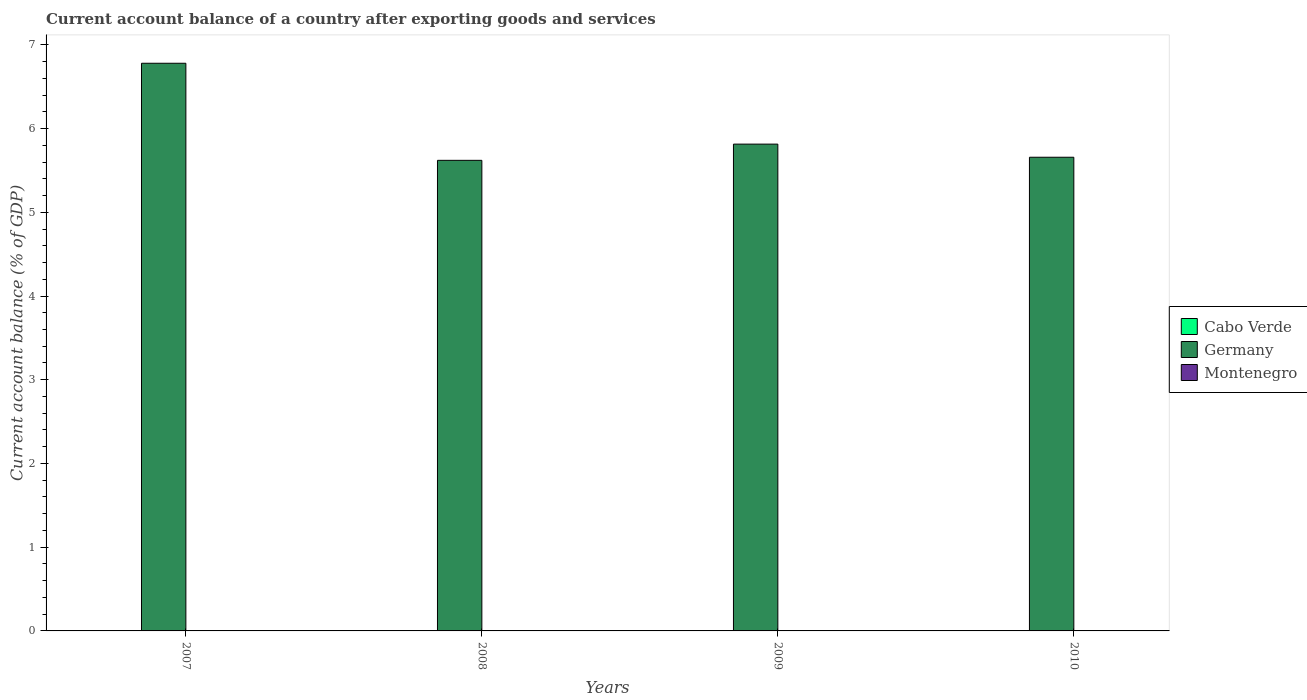How many bars are there on the 4th tick from the left?
Your response must be concise. 1. What is the label of the 4th group of bars from the left?
Give a very brief answer. 2010. In how many cases, is the number of bars for a given year not equal to the number of legend labels?
Offer a very short reply. 4. What is the account balance in Germany in 2009?
Your answer should be compact. 5.81. Across all years, what is the maximum account balance in Germany?
Offer a terse response. 6.78. Across all years, what is the minimum account balance in Germany?
Offer a very short reply. 5.62. In which year was the account balance in Germany maximum?
Provide a short and direct response. 2007. What is the difference between the account balance in Germany in 2009 and that in 2010?
Your answer should be compact. 0.16. What is the average account balance in Germany per year?
Your answer should be very brief. 5.97. In how many years, is the account balance in Cabo Verde greater than 1.2 %?
Provide a succinct answer. 0. What is the ratio of the account balance in Germany in 2008 to that in 2009?
Give a very brief answer. 0.97. Is the account balance in Germany in 2007 less than that in 2009?
Provide a short and direct response. No. What is the difference between the highest and the second highest account balance in Germany?
Make the answer very short. 0.97. What is the difference between the highest and the lowest account balance in Germany?
Ensure brevity in your answer.  1.16. In how many years, is the account balance in Montenegro greater than the average account balance in Montenegro taken over all years?
Provide a short and direct response. 0. Is it the case that in every year, the sum of the account balance in Germany and account balance in Montenegro is greater than the account balance in Cabo Verde?
Make the answer very short. Yes. Are all the bars in the graph horizontal?
Provide a short and direct response. No. What is the difference between two consecutive major ticks on the Y-axis?
Offer a terse response. 1. Are the values on the major ticks of Y-axis written in scientific E-notation?
Ensure brevity in your answer.  No. Does the graph contain grids?
Your answer should be very brief. No. How many legend labels are there?
Ensure brevity in your answer.  3. What is the title of the graph?
Give a very brief answer. Current account balance of a country after exporting goods and services. Does "Israel" appear as one of the legend labels in the graph?
Ensure brevity in your answer.  No. What is the label or title of the X-axis?
Ensure brevity in your answer.  Years. What is the label or title of the Y-axis?
Offer a very short reply. Current account balance (% of GDP). What is the Current account balance (% of GDP) of Germany in 2007?
Provide a succinct answer. 6.78. What is the Current account balance (% of GDP) in Montenegro in 2007?
Your answer should be compact. 0. What is the Current account balance (% of GDP) of Cabo Verde in 2008?
Give a very brief answer. 0. What is the Current account balance (% of GDP) of Germany in 2008?
Offer a very short reply. 5.62. What is the Current account balance (% of GDP) in Montenegro in 2008?
Keep it short and to the point. 0. What is the Current account balance (% of GDP) of Germany in 2009?
Offer a very short reply. 5.81. What is the Current account balance (% of GDP) in Germany in 2010?
Offer a very short reply. 5.66. What is the Current account balance (% of GDP) of Montenegro in 2010?
Your response must be concise. 0. Across all years, what is the maximum Current account balance (% of GDP) of Germany?
Provide a short and direct response. 6.78. Across all years, what is the minimum Current account balance (% of GDP) in Germany?
Offer a very short reply. 5.62. What is the total Current account balance (% of GDP) of Cabo Verde in the graph?
Your response must be concise. 0. What is the total Current account balance (% of GDP) of Germany in the graph?
Your answer should be compact. 23.87. What is the total Current account balance (% of GDP) of Montenegro in the graph?
Make the answer very short. 0. What is the difference between the Current account balance (% of GDP) in Germany in 2007 and that in 2008?
Give a very brief answer. 1.16. What is the difference between the Current account balance (% of GDP) of Germany in 2007 and that in 2009?
Offer a very short reply. 0.97. What is the difference between the Current account balance (% of GDP) in Germany in 2007 and that in 2010?
Keep it short and to the point. 1.12. What is the difference between the Current account balance (% of GDP) of Germany in 2008 and that in 2009?
Provide a succinct answer. -0.19. What is the difference between the Current account balance (% of GDP) in Germany in 2008 and that in 2010?
Ensure brevity in your answer.  -0.04. What is the difference between the Current account balance (% of GDP) in Germany in 2009 and that in 2010?
Your answer should be very brief. 0.16. What is the average Current account balance (% of GDP) in Germany per year?
Your answer should be very brief. 5.97. What is the average Current account balance (% of GDP) in Montenegro per year?
Give a very brief answer. 0. What is the ratio of the Current account balance (% of GDP) of Germany in 2007 to that in 2008?
Offer a terse response. 1.21. What is the ratio of the Current account balance (% of GDP) in Germany in 2007 to that in 2009?
Ensure brevity in your answer.  1.17. What is the ratio of the Current account balance (% of GDP) of Germany in 2007 to that in 2010?
Keep it short and to the point. 1.2. What is the ratio of the Current account balance (% of GDP) in Germany in 2008 to that in 2009?
Your answer should be compact. 0.97. What is the ratio of the Current account balance (% of GDP) of Germany in 2009 to that in 2010?
Keep it short and to the point. 1.03. What is the difference between the highest and the second highest Current account balance (% of GDP) in Germany?
Keep it short and to the point. 0.97. What is the difference between the highest and the lowest Current account balance (% of GDP) in Germany?
Ensure brevity in your answer.  1.16. 